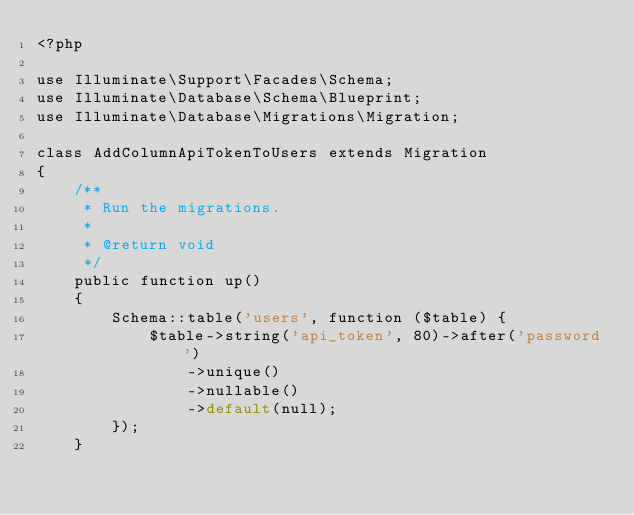<code> <loc_0><loc_0><loc_500><loc_500><_PHP_><?php

use Illuminate\Support\Facades\Schema;
use Illuminate\Database\Schema\Blueprint;
use Illuminate\Database\Migrations\Migration;

class AddColumnApiTokenToUsers extends Migration
{
    /**
     * Run the migrations.
     *
     * @return void
     */
    public function up()
    {
        Schema::table('users', function ($table) {
            $table->string('api_token', 80)->after('password')
                ->unique()
                ->nullable()
                ->default(null);
        });
    }
</code> 